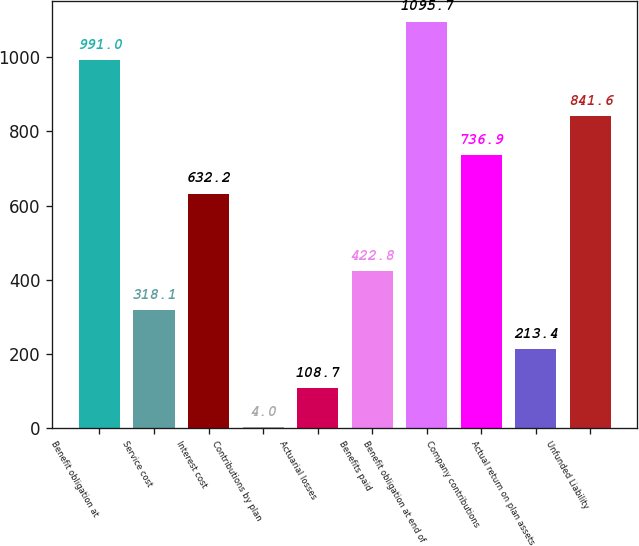Convert chart. <chart><loc_0><loc_0><loc_500><loc_500><bar_chart><fcel>Benefit obligation at<fcel>Service cost<fcel>Interest cost<fcel>Contributions by plan<fcel>Actuarial losses<fcel>Benefits paid<fcel>Benefit obligation at end of<fcel>Company contributions<fcel>Actual return on plan assets<fcel>Unfunded Liability<nl><fcel>991<fcel>318.1<fcel>632.2<fcel>4<fcel>108.7<fcel>422.8<fcel>1095.7<fcel>736.9<fcel>213.4<fcel>841.6<nl></chart> 